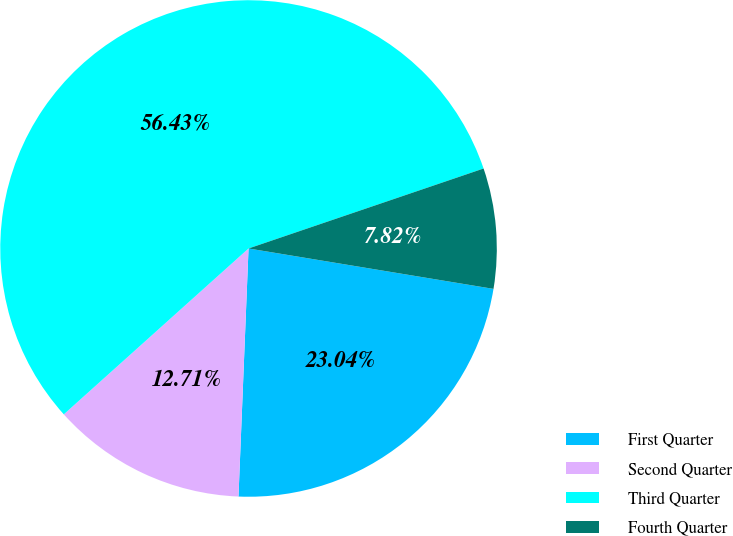Convert chart to OTSL. <chart><loc_0><loc_0><loc_500><loc_500><pie_chart><fcel>First Quarter<fcel>Second Quarter<fcel>Third Quarter<fcel>Fourth Quarter<nl><fcel>23.04%<fcel>12.71%<fcel>56.42%<fcel>7.82%<nl></chart> 